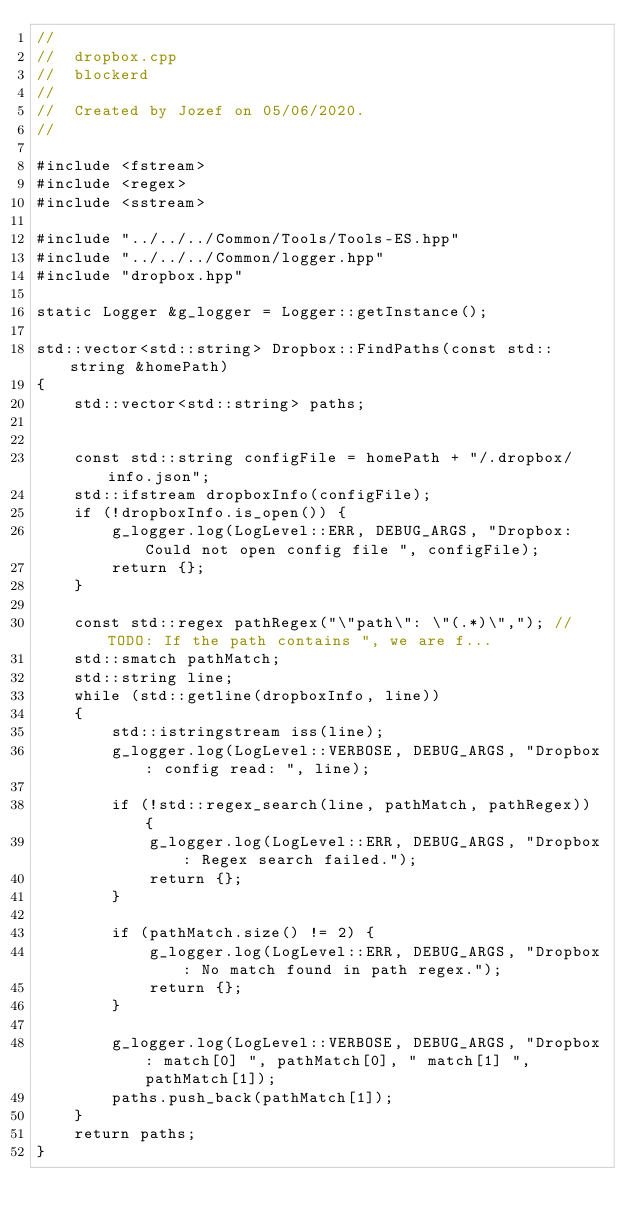<code> <loc_0><loc_0><loc_500><loc_500><_ObjectiveC_>//
//  dropbox.cpp
//  blockerd
//
//  Created by Jozef on 05/06/2020.
//

#include <fstream>
#include <regex>
#include <sstream>

#include "../../../Common/Tools/Tools-ES.hpp"
#include "../../../Common/logger.hpp"
#include "dropbox.hpp"

static Logger &g_logger = Logger::getInstance();

std::vector<std::string> Dropbox::FindPaths(const std::string &homePath)
{
    std::vector<std::string> paths;


    const std::string configFile = homePath + "/.dropbox/info.json";
    std::ifstream dropboxInfo(configFile);
    if (!dropboxInfo.is_open()) {
        g_logger.log(LogLevel::ERR, DEBUG_ARGS, "Dropbox: Could not open config file ", configFile);
        return {};
    }

    const std::regex pathRegex("\"path\": \"(.*)\","); // TODO: If the path contains ", we are f...
    std::smatch pathMatch;
    std::string line;
    while (std::getline(dropboxInfo, line))
    {
        std::istringstream iss(line);
        g_logger.log(LogLevel::VERBOSE, DEBUG_ARGS, "Dropbox: config read: ", line);

        if (!std::regex_search(line, pathMatch, pathRegex)) {
            g_logger.log(LogLevel::ERR, DEBUG_ARGS, "Dropbox: Regex search failed.");
            return {};
        }

        if (pathMatch.size() != 2) {
            g_logger.log(LogLevel::ERR, DEBUG_ARGS, "Dropbox: No match found in path regex.");
            return {};
        }

        g_logger.log(LogLevel::VERBOSE, DEBUG_ARGS, "Dropbox: match[0] ", pathMatch[0], " match[1] ", pathMatch[1]);
        paths.push_back(pathMatch[1]);
    }
    return paths;
}
</code> 